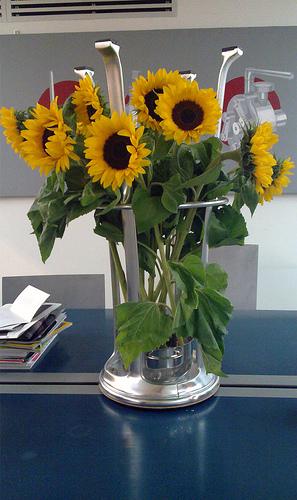How many sunflowers?
Answer briefly. 8. What country do these flowers originate from?
Concise answer only. Usa. Is this black and white?
Keep it brief. No. Did someone order these?
Keep it brief. No. Are the flowers orange?
Keep it brief. No. What color is the table the vase of flowers is resting on?
Quick response, please. Blue. What type of flower is in the picture?
Quick response, please. Sunflower. What type of flower is in the vase?
Give a very brief answer. Sunflower. Are all the flowers open?
Keep it brief. Yes. What color are the flowers?
Short answer required. Yellow. 